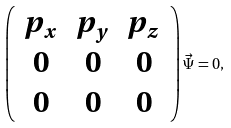Convert formula to latex. <formula><loc_0><loc_0><loc_500><loc_500>\left ( \begin{array} { c c c } p _ { x } & p _ { y } & p _ { z } \\ 0 & 0 & 0 \\ 0 & 0 & 0 \end{array} \right ) \vec { \Psi } = 0 ,</formula> 